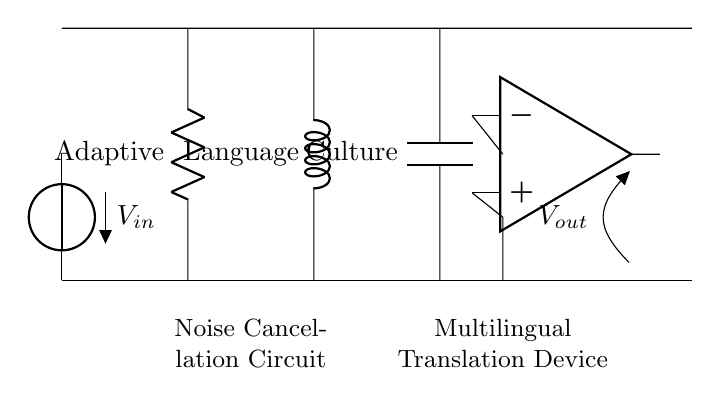What voltage source is used in the circuit? The circuit uses a voltage source labeled as V_in, which is the input voltage for the noise cancellation circuit.
Answer: V_in What is the role of the resistor in this circuit? The resistor, labeled as Adaptive, is part of the RLC circuit and helps to control the flow of current, affecting the overall impedance and damping of the circuit.
Answer: Adaptive How many components are there in this circuit? There are four main components: one resistor, one inductor, one capacitor, and one operational amplifier. Counting these gives a total of four components.
Answer: Four What does the inductor represent in this circuit? The inductor is labeled as Language and is used to store energy in a magnetic field, contributing to the circuit's dynamic response to varying frequencies of noise.
Answer: Language What is the purpose of the capacitor in this RLC circuit? The capacitor, labeled as Culture, helps to filter out high-frequency noise by storing and releasing electrical energy, thus aiding in noise cancellation for the translation device.
Answer: Culture How do the components of this circuit work together? The resistor, inductor, and capacitor work in tandem to create a resonance condition that helps filter unwanted noise, making the input signal clearer for the multilingual translation.
Answer: Noise cancellation 